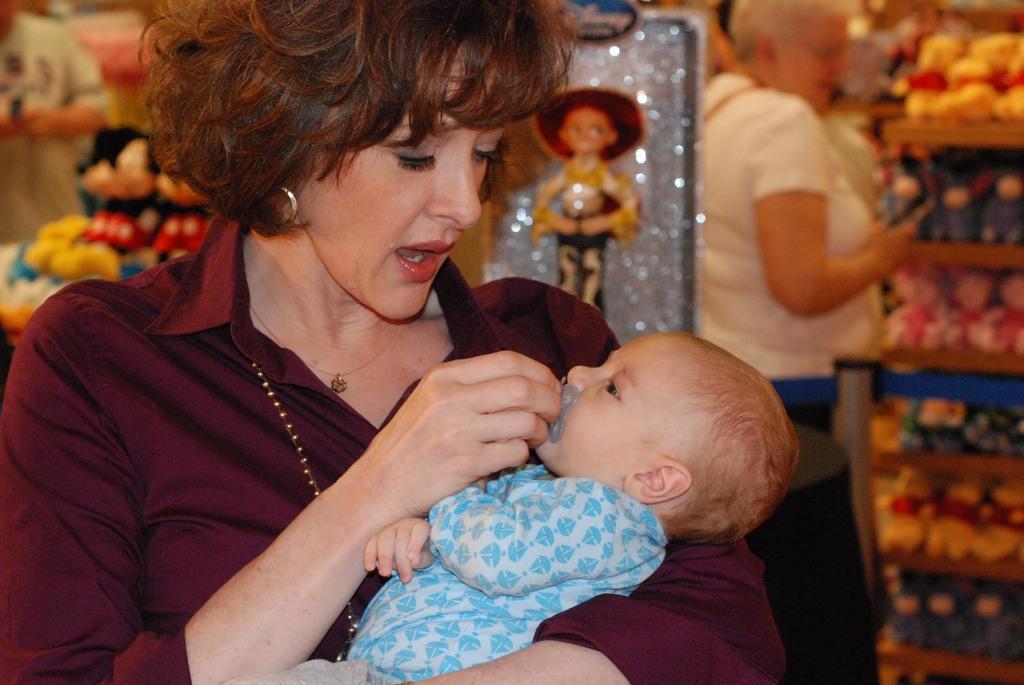Please provide a concise description of this image. In this image, we can see a lady holding baby and in the background, there are toys and we can see some people standing. 